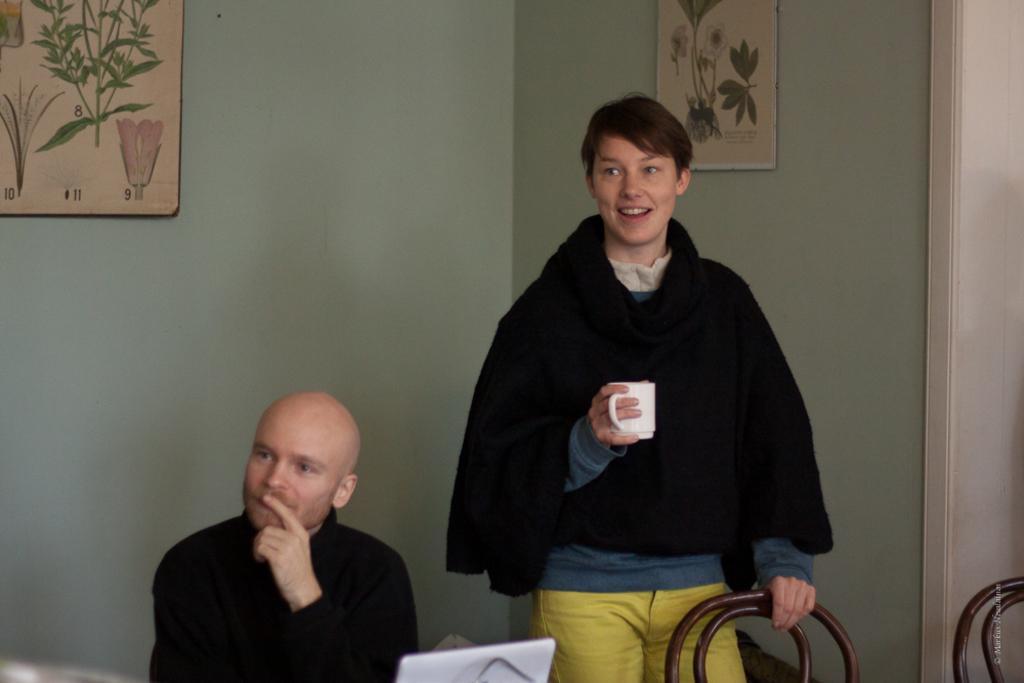Can you describe this image briefly? Here I can see a person wearing a black color jacket, holding a cup and a chair, standing and smiling. Beside this person there is another person wearing black color dress and sitting. Both are looking at the left side. At the bottom there is a laptop. In the background there are two frames attached to the wall. 